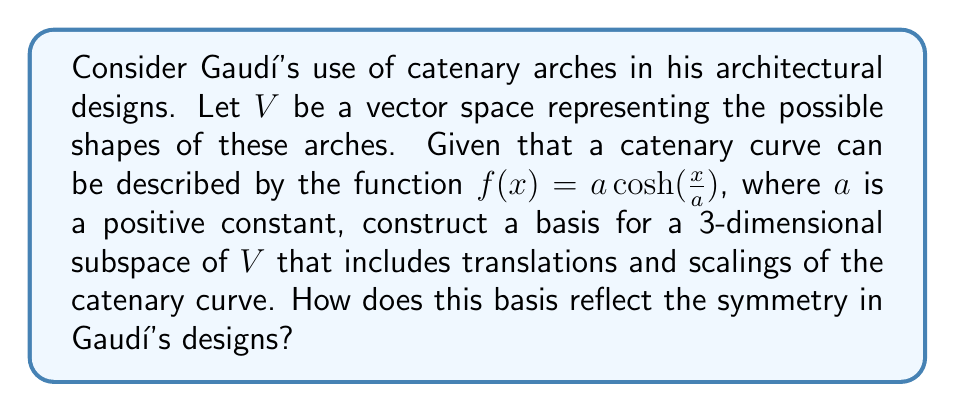Give your solution to this math problem. To approach this problem, we'll follow these steps:

1) First, let's consider the general form of a catenary curve:
   $$f(x) = a \cosh(\frac{x}{a})$$

2) We want to create a 3-dimensional subspace that includes translations and scalings. Let's define our basis vectors:

   a) $v_1(x) = \cosh(x)$ (the basic catenary shape)
   b) $v_2(x) = x \sinh(x)$ (a scaling transformation)
   c) $v_3(x) = 1$ (a vertical translation)

3) These vectors are linearly independent and span a 3-dimensional subspace of $V$. Any vector in this subspace can be written as a linear combination of these basis vectors:

   $$g(x) = c_1 \cosh(x) + c_2 x \sinh(x) + c_3$$

4) This basis reflects symmetry in Gaudí's designs in several ways:

   a) $v_1(x)$ is symmetric about the y-axis, reflecting the bilateral symmetry often seen in Gaudí's arches.
   
   b) $v_2(x)$ allows for scaling transformations, which Gaudí used to create varying arch heights and widths while maintaining the catenary shape.
   
   c) $v_3(x)$ enables vertical translations, allowing the arch to be positioned at different heights within a structure.

5) The combination of these basis vectors allows for a wide range of catenary-based shapes, providing the flexibility Gaudí needed to integrate these forms into his complex, organic designs.

6) The symmetry of the catenary curve (represented by $v_1(x)$) is preserved under the transformations allowed by $v_2(x)$ and $v_3(x)$, which aligns with Gaudí's use of balanced, harmonious forms in his architecture.
Answer: The basis $\{v_1(x) = \cosh(x), v_2(x) = x \sinh(x), v_3(x) = 1\}$ for the 3-dimensional subspace reflects the symmetry in Gaudí's designs by preserving the bilateral symmetry of the catenary curve while allowing for scaling and translation transformations. This combination enables the creation of varied yet balanced arch forms, characteristic of Gaudí's organic and harmonious architectural style. 